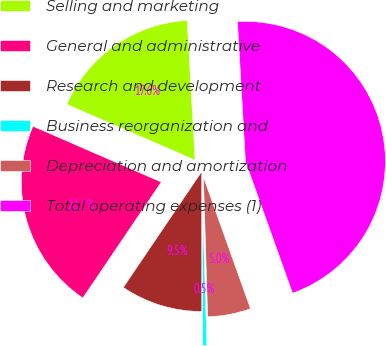<chart> <loc_0><loc_0><loc_500><loc_500><pie_chart><fcel>Selling and marketing<fcel>General and administrative<fcel>Research and development<fcel>Business reorganization and<fcel>Depreciation and amortization<fcel>Total operating expenses (1)<nl><fcel>17.56%<fcel>22.06%<fcel>9.47%<fcel>0.48%<fcel>4.98%<fcel>45.44%<nl></chart> 